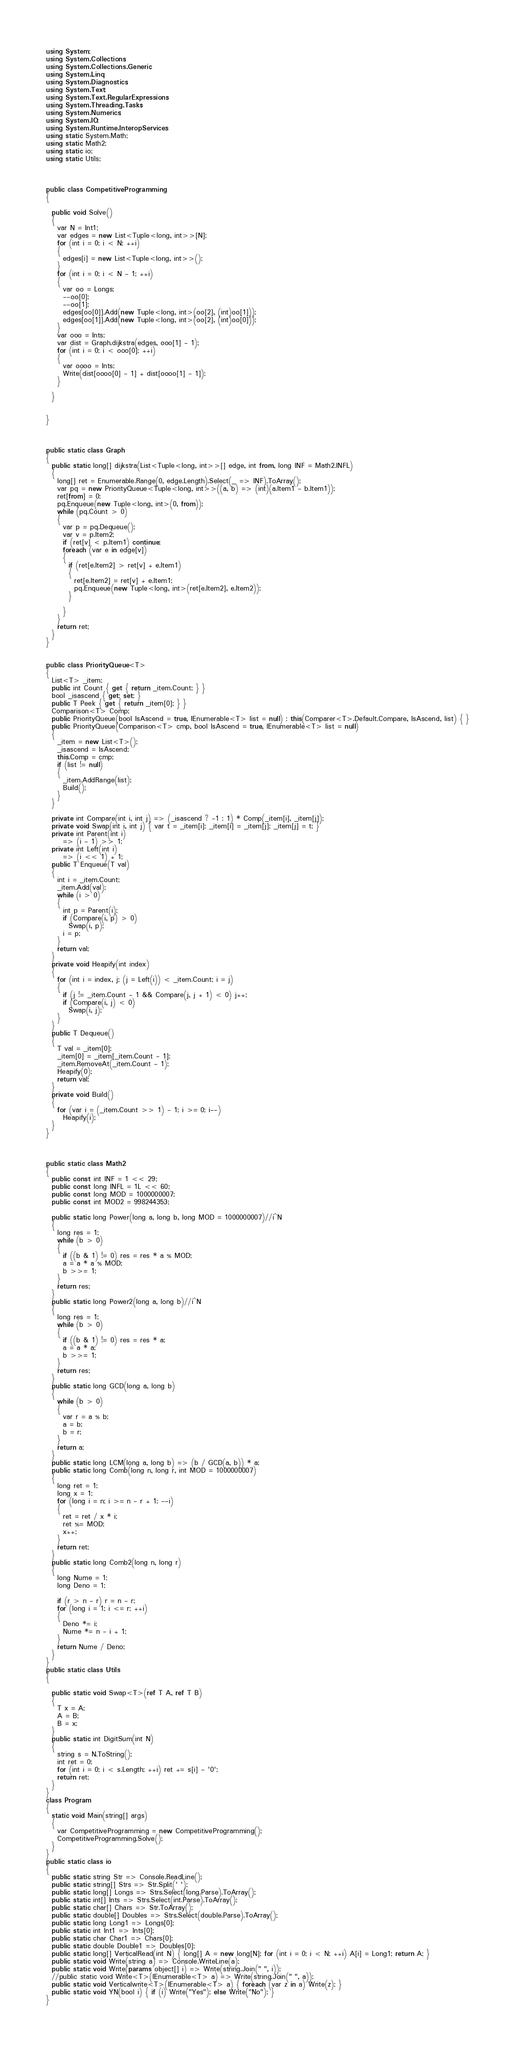Convert code to text. <code><loc_0><loc_0><loc_500><loc_500><_C#_>using System;
using System.Collections;
using System.Collections.Generic;
using System.Linq;
using System.Diagnostics;
using System.Text;
using System.Text.RegularExpressions;
using System.Threading.Tasks;
using System.Numerics;
using System.IO;
using System.Runtime.InteropServices;
using static System.Math;
using static Math2;
using static io;
using static Utils;



public class CompetitiveProgramming
{

  public void Solve()
  {
    var N = Int1;
    var edges = new List<Tuple<long, int>>[N];
    for (int i = 0; i < N; ++i)
    {
      edges[i] = new List<Tuple<long, int>>();
    }
    for (int i = 0; i < N - 1; ++i)
    {
      var oo = Longs;
      --oo[0];
      --oo[1];
      edges[oo[0]].Add(new Tuple<long, int>(oo[2], (int)oo[1]));
      edges[oo[1]].Add(new Tuple<long, int>(oo[2], (int)oo[0]));
    }
    var ooo = Ints;
    var dist = Graph.dijkstra(edges, ooo[1] - 1);
    for (int i = 0; i < ooo[0]; ++i)
    {
      var oooo = Ints;
      Write(dist[oooo[0] - 1] + dist[oooo[1] - 1]);
    }

  }


}



public static class Graph
{
  public static long[] dijkstra(List<Tuple<long, int>>[] edge, int from, long INF = Math2.INFL)
  {
    long[] ret = Enumerable.Range(0, edge.Length).Select(_ => INF).ToArray();
    var pq = new PriorityQueue<Tuple<long, int>>((a, b) => (int)(a.Item1 - b.Item1));
    ret[from] = 0;
    pq.Enqueue(new Tuple<long, int>(0, from));
    while (pq.Count > 0)
    {
      var p = pq.Dequeue();
      var v = p.Item2;
      if (ret[v] < p.Item1) continue;
      foreach (var e in edge[v])
      {
        if (ret[e.Item2] > ret[v] + e.Item1)
        {
          ret[e.Item2] = ret[v] + e.Item1;
          pq.Enqueue(new Tuple<long, int>(ret[e.Item2], e.Item2));
        }

      }
    }
    return ret;
  }
}


public class PriorityQueue<T>
{
  List<T> _item;
  public int Count { get { return _item.Count; } }
  bool _isascend { get; set; }
  public T Peek { get { return _item[0]; } }
  Comparison<T> Comp;
  public PriorityQueue(bool IsAscend = true, IEnumerable<T> list = null) : this(Comparer<T>.Default.Compare, IsAscend, list) { }
  public PriorityQueue(Comparison<T> cmp, bool IsAscend = true, IEnumerable<T> list = null)
  {
    _item = new List<T>();
    _isascend = IsAscend;
    this.Comp = cmp;
    if (list != null)
    {
      _item.AddRange(list);
      Build();
    }
  }

  private int Compare(int i, int j) => (_isascend ? -1 : 1) * Comp(_item[i], _item[j]);
  private void Swap(int i, int j) { var t = _item[i]; _item[i] = _item[j]; _item[j] = t; }
  private int Parent(int i)
      => (i - 1) >> 1;
  private int Left(int i)
      => (i << 1) + 1;
  public T Enqueue(T val)
  {
    int i = _item.Count;
    _item.Add(val);
    while (i > 0)
    {
      int p = Parent(i);
      if (Compare(i, p) > 0)
        Swap(i, p);
      i = p;
    }
    return val;
  }
  private void Heapify(int index)
  {
    for (int i = index, j; (j = Left(i)) < _item.Count; i = j)
    {
      if (j != _item.Count - 1 && Compare(j, j + 1) < 0) j++;
      if (Compare(i, j) < 0)
        Swap(i, j);
    }
  }
  public T Dequeue()
  {
    T val = _item[0];
    _item[0] = _item[_item.Count - 1];
    _item.RemoveAt(_item.Count - 1);
    Heapify(0);
    return val;
  }
  private void Build()
  {
    for (var i = (_item.Count >> 1) - 1; i >= 0; i--)
      Heapify(i);
  }
}



public static class Math2
{
  public const int INF = 1 << 29;
  public const long INFL = 1L << 60;
  public const long MOD = 1000000007;
  public const int MOD2 = 998244353;

  public static long Power(long a, long b, long MOD = 1000000007)//i^N
  {
    long res = 1;
    while (b > 0)
    {
      if ((b & 1) != 0) res = res * a % MOD;
      a = a * a % MOD;
      b >>= 1;
    }
    return res;
  }
  public static long Power2(long a, long b)//i^N
  {
    long res = 1;
    while (b > 0)
    {
      if ((b & 1) != 0) res = res * a;
      a = a * a;
      b >>= 1;
    }
    return res;
  }
  public static long GCD(long a, long b)
  {
    while (b > 0)
    {
      var r = a % b;
      a = b;
      b = r;
    }
    return a;
  }
  public static long LCM(long a, long b) => (b / GCD(a, b)) * a;
  public static long Comb(long n, long r, int MOD = 1000000007)
  {
    long ret = 1;
    long x = 1;
    for (long i = n; i >= n - r + 1; --i)
    {
      ret = ret / x * i;
      ret %= MOD;
      x++;
    }
    return ret;
  }
  public static long Comb2(long n, long r)
  {
    long Nume = 1;
    long Deno = 1;

    if (r > n - r) r = n - r;
    for (long i = 1; i <= r; ++i)
    {
      Deno *= i;
      Nume *= n - i + 1;
    }
    return Nume / Deno;
  }
}
public static class Utils
{

  public static void Swap<T>(ref T A, ref T B)
  {
    T x = A;
    A = B;
    B = x;
  }
  public static int DigitSum(int N)
  {
    string s = N.ToString();
    int ret = 0;
    for (int i = 0; i < s.Length; ++i) ret += s[i] - '0';
    return ret;
  }
}
class Program
{
  static void Main(string[] args)
  {
    var CompetitiveProgramming = new CompetitiveProgramming();
    CompetitiveProgramming.Solve();
  }
}
public static class io
{
  public static string Str => Console.ReadLine();
  public static string[] Strs => Str.Split(' ');
  public static long[] Longs => Strs.Select(long.Parse).ToArray();
  public static int[] Ints => Strs.Select(int.Parse).ToArray();
  public static char[] Chars => Str.ToArray();
  public static double[] Doubles => Strs.Select(double.Parse).ToArray();
  public static long Long1 => Longs[0];
  public static int Int1 => Ints[0];
  public static char Char1 => Chars[0];
  public static double Double1 => Doubles[0];
  public static long[] VerticalRead(int N) { long[] A = new long[N]; for (int i = 0; i < N; ++i) A[i] = Long1; return A; }
  public static void Write(string a) => Console.WriteLine(a);
  public static void Write(params object[] i) => Write(string.Join(" ", i));
  //public static void Write<T>(IEnumerable<T> a) => Write(string.Join(" ", a));
  public static void Verticalwrite<T>(IEnumerable<T> a) { foreach (var z in a) Write(z); }
  public static void YN(bool i) { if (i) Write("Yes"); else Write("No"); }
}
</code> 